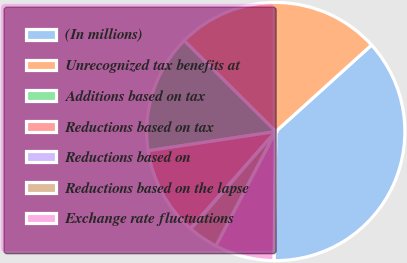<chart> <loc_0><loc_0><loc_500><loc_500><pie_chart><fcel>(In millions)<fcel>Unrecognized tax benefits at<fcel>Additions based on tax<fcel>Reductions based on tax<fcel>Reductions based on<fcel>Reductions based on the lapse<fcel>Exchange rate fluctuations<nl><fcel>36.92%<fcel>25.87%<fcel>14.81%<fcel>11.13%<fcel>0.07%<fcel>3.76%<fcel>7.44%<nl></chart> 